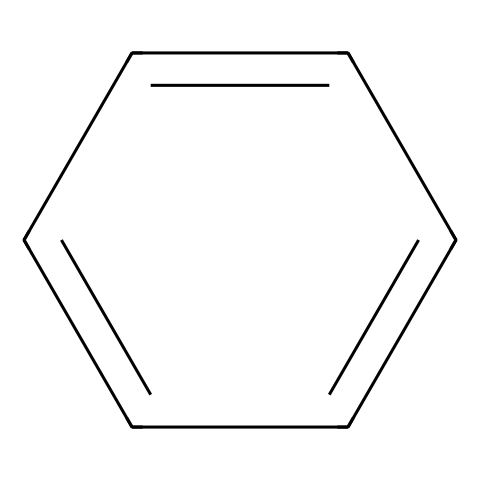What is the name of this chemical? The chemical structure represented by the SMILES notation c1ccccc1 corresponds to benzene, recognized for its aromatic properties.
Answer: benzene How many carbon atoms are in this structure? The structure indicates the presence of six carbon atoms, as each vertex or end of a line in the aromatic ring represents a carbon.
Answer: six What is the bond type between the carbon atoms in this molecule? The carbon atoms in benzene are connected by alternating single and double bonds, forming a specific resonance structure known as aromatic bonding.
Answer: aromatic What is the total number of hydrogen atoms attached to this compound? Each of the six carbon atoms in benzene is bonded to one hydrogen atom, resulting in a total of six hydrogen atoms surrounding the aromatic ring.
Answer: six How does the molecular structure of benzene contribute to its stability? The conjugated system of alternating double bonds allows for delocalization of electrons over the ring, which enhances stability and lowers reactivity compared to non-aromatic compounds.
Answer: delocalization What aromatic property does benzene exhibit? Benzene exhibits aromaticity, a property that confirms its cyclic structure and resonance stabilization due to conjugated pi bonds, differentiating it from aliphatic compounds.
Answer: aromaticity 